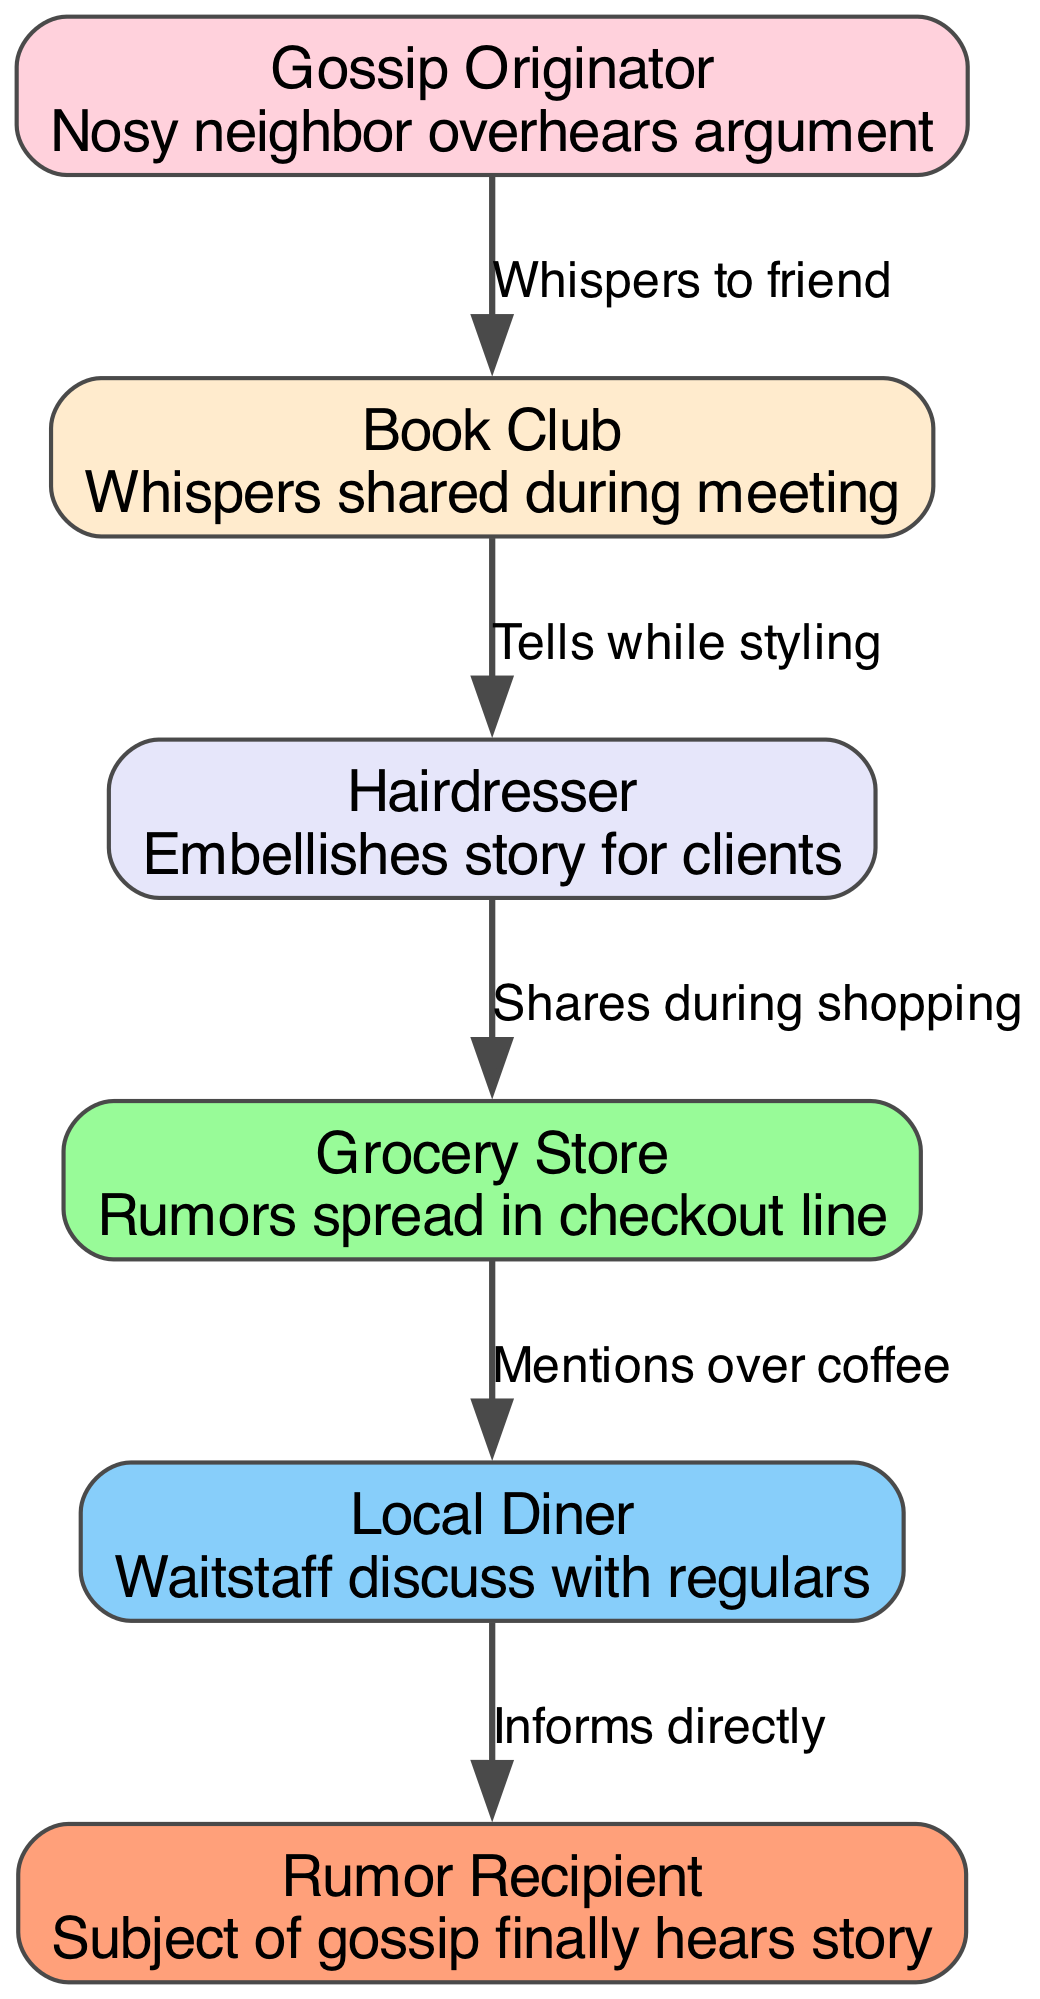What is the first node in the food chain? The first node represents the originator of the gossip, which is "Gossip Originator" who "Nosy neighbor overhears argument."
Answer: Gossip Originator How many nodes are in the food chain? To find the total number of nodes, we count the entries in the 'chain' list which includes 6 different roles from originator to recipient.
Answer: 6 What does the last node describe? The last node "Rumor Recipient" indicates who ultimately hears the gossip and is described as "Subject of gossip finally hears story."
Answer: Subject of gossip finally hears story Which node discusses gossip with regulars? The node that discusses gossip with regulars is "Local Diner," which has the description "Waitstaff discuss with regulars."
Answer: Local Diner What is the relationship between the Hairdresser and the Grocery Store? The Hairdresser provides gossip to the Grocery Store, specifically through the action described as "Shares during shopping," linking them sequentially in the flow of gossip.
Answer: Shares during shopping Who embellishes the story? The node that embellishes the story for clients is "Hairdresser," known for adding dramatic details while styling hair.
Answer: Hairdresser What is the color of the Grocery Store node? Each node has a specific color and the Grocery Store node is the fourth one, which corresponds to its assigned color in the palette.
Answer: #98FB98 What does "Whispers to friend" indicate? "Whispers to friend" refers to the arrow connecting the Gossip Originator to the Book Club, indicating how gossip is first spread informally between close acquaintances.
Answer: Whispers to friend What action connects the Book Club to the Hairdresser? The action that links these two nodes is described as "Tells while styling," transitioning gossip as it travels from the Book Club to the Hairdresser.
Answer: Tells while styling 